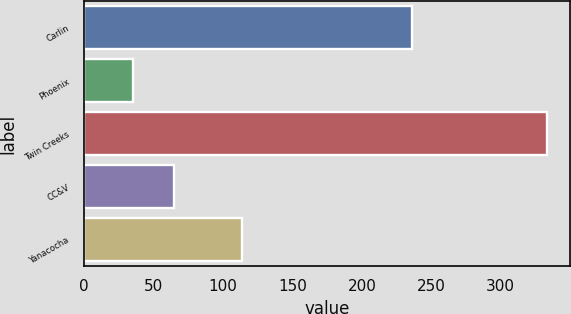<chart> <loc_0><loc_0><loc_500><loc_500><bar_chart><fcel>Carlin<fcel>Phoenix<fcel>Twin Creeks<fcel>CC&V<fcel>Yanacocha<nl><fcel>236<fcel>35<fcel>333<fcel>64.8<fcel>114<nl></chart> 